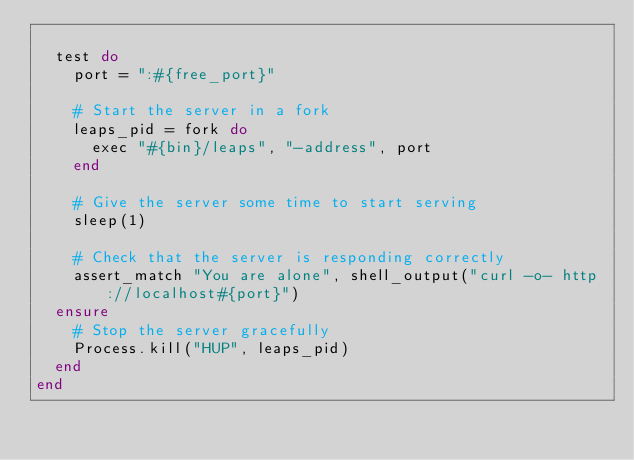<code> <loc_0><loc_0><loc_500><loc_500><_Ruby_>
  test do
    port = ":#{free_port}"

    # Start the server in a fork
    leaps_pid = fork do
      exec "#{bin}/leaps", "-address", port
    end

    # Give the server some time to start serving
    sleep(1)

    # Check that the server is responding correctly
    assert_match "You are alone", shell_output("curl -o- http://localhost#{port}")
  ensure
    # Stop the server gracefully
    Process.kill("HUP", leaps_pid)
  end
end
</code> 